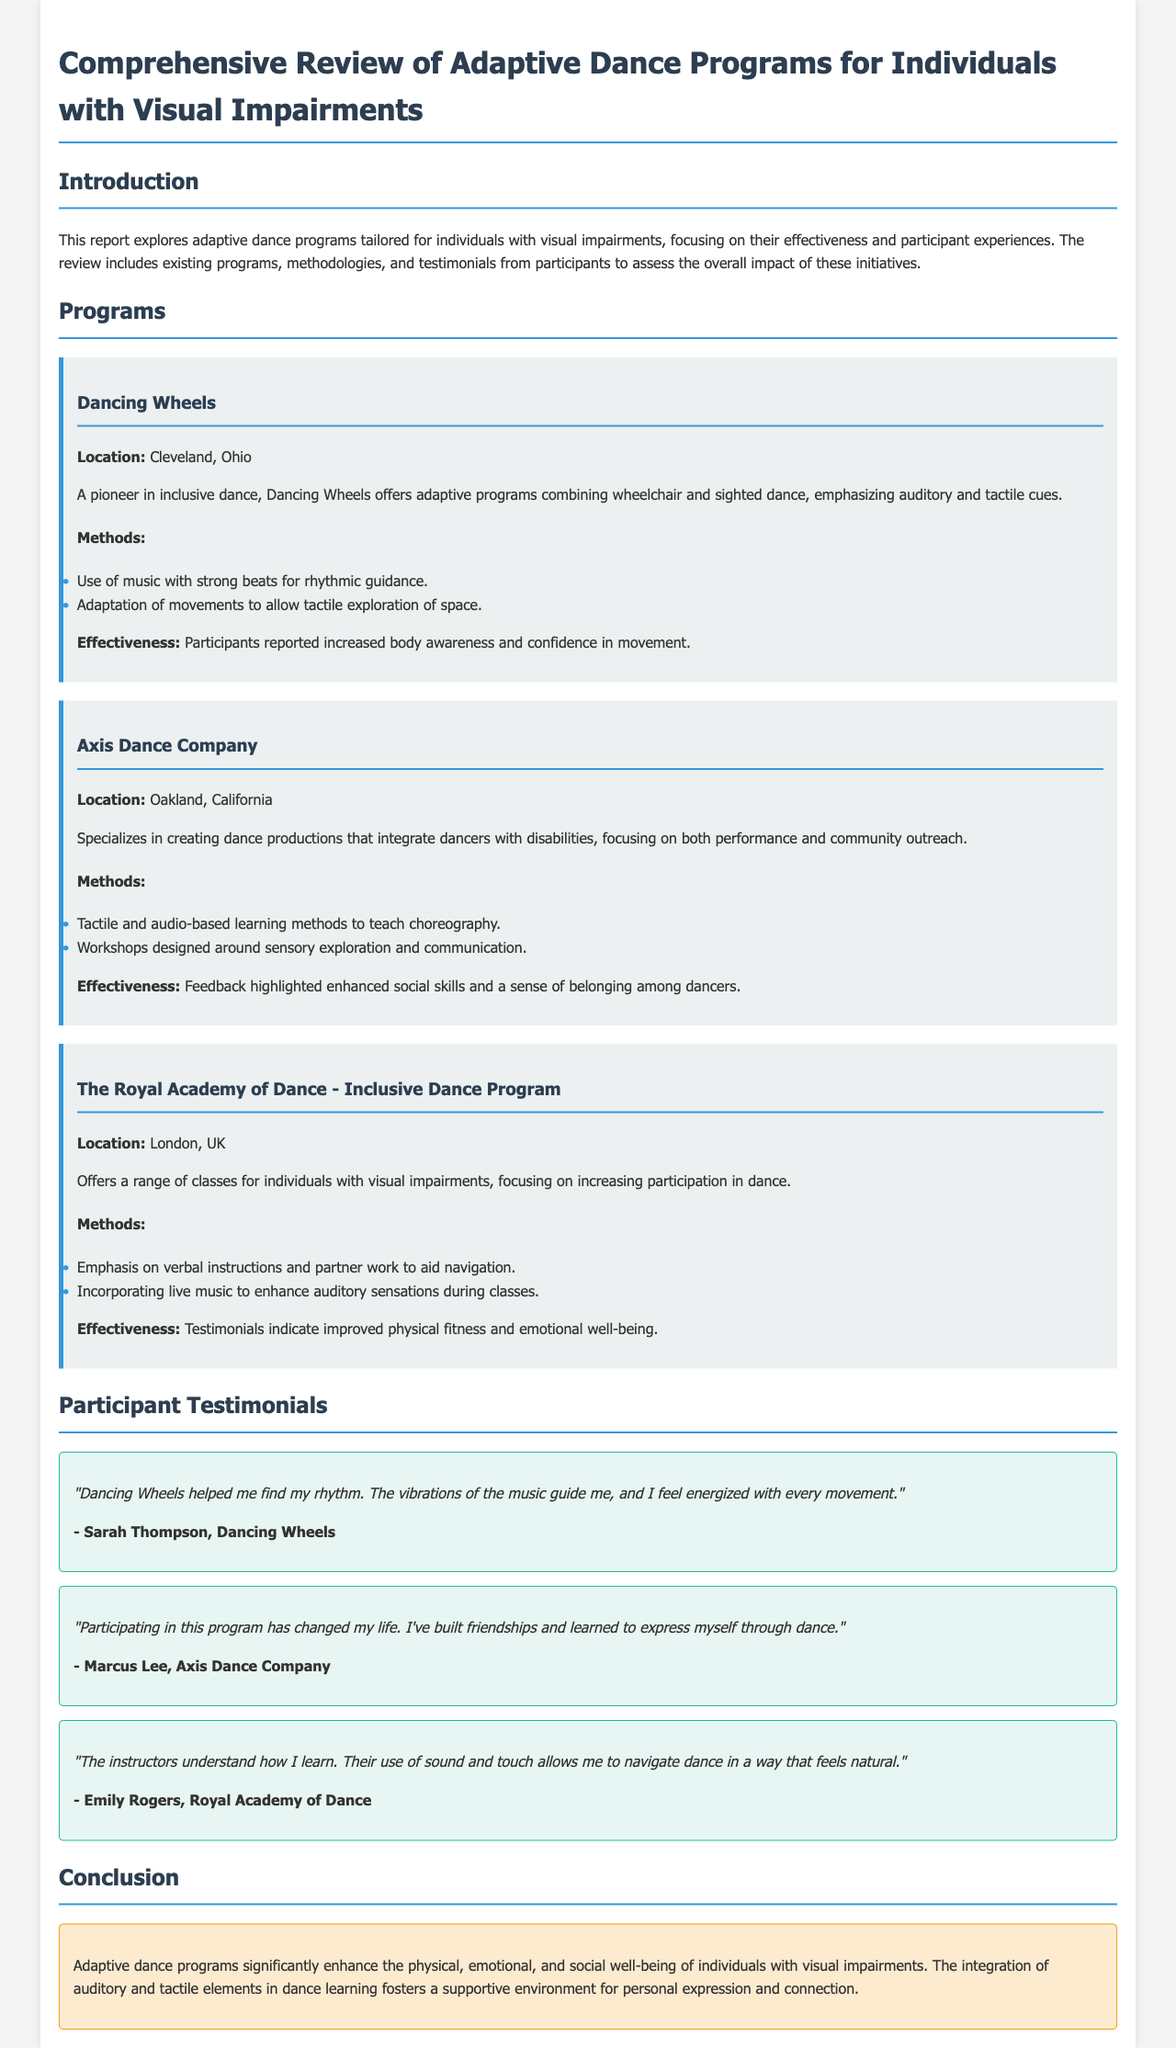What is the name of the program in Cleveland, Ohio? The program in Cleveland, Ohio is called Dancing Wheels.
Answer: Dancing Wheels What is a method used by Axis Dance Company? Axis Dance Company uses tactile and audio-based learning methods to teach choreography.
Answer: Tactile and audio-based learning methods What does the Royal Academy of Dance emphasize in its classes? The Royal Academy of Dance emphasizes verbal instructions and partner work to aid navigation.
Answer: Verbal instructions and partner work Which participant mentioned finding their rhythm? Sarah Thompson from Dancing Wheels mentioned finding her rhythm.
Answer: Sarah Thompson What aspect of well-being did participants report improvements in? Participants reported improvements in physical fitness and emotional well-being.
Answer: Physical fitness and emotional well-being How many programs are discussed in the document? The document discusses three programs.
Answer: Three What is the primary focus of the report? The primary focus of the report is adaptive dance programs for individuals with visual impairments.
Answer: Adaptive dance programs for individuals with visual impairments Which program highlighted enhanced social skills? Axis Dance Company highlighted enhanced social skills.
Answer: Axis Dance Company What is the conclusion about adaptive dance programs? The conclusion states that adaptive dance programs significantly enhance the physical, emotional, and social well-being.
Answer: Significantly enhance physical, emotional, and social well-being 